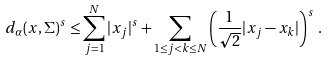Convert formula to latex. <formula><loc_0><loc_0><loc_500><loc_500>d _ { \alpha } ( { x } , \Sigma ) ^ { s } \leq \sum _ { j = 1 } ^ { N } | x _ { j } | ^ { s } + \sum _ { 1 \leq j < k \leq N } \left ( \frac { 1 } { \sqrt { 2 } } | x _ { j } - x _ { k } | \right ) ^ { s } \, .</formula> 